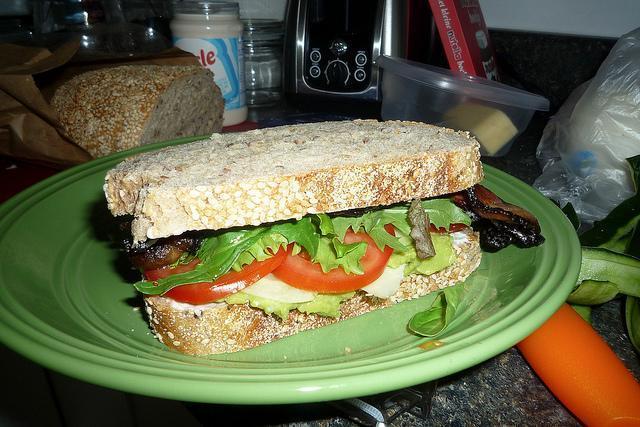How many bowls are in the photo?
Give a very brief answer. 1. 